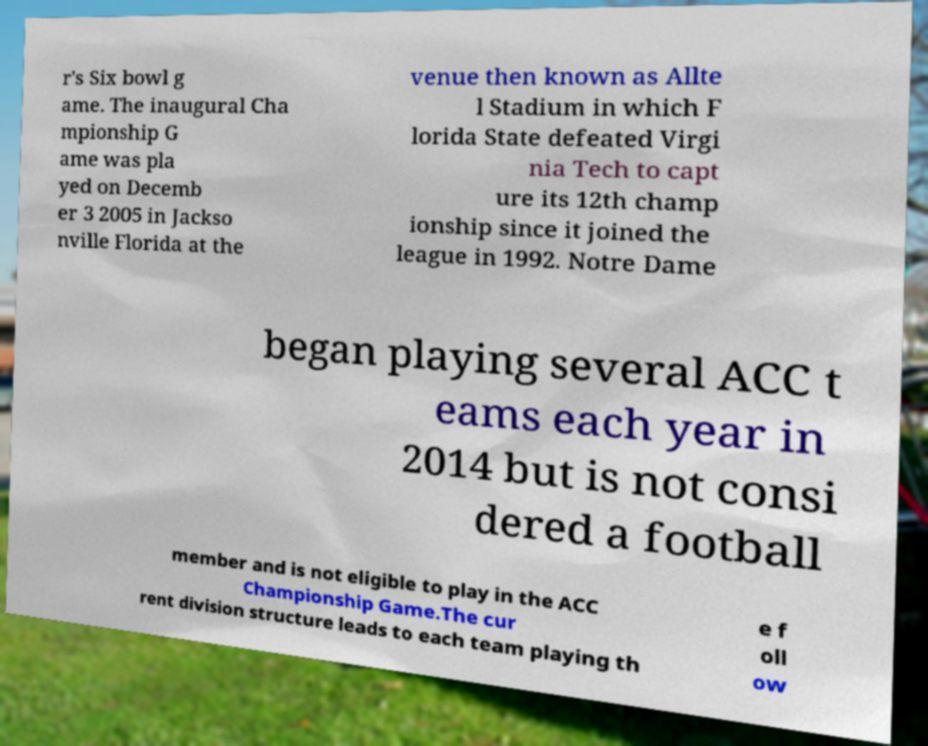Please identify and transcribe the text found in this image. r's Six bowl g ame. The inaugural Cha mpionship G ame was pla yed on Decemb er 3 2005 in Jackso nville Florida at the venue then known as Allte l Stadium in which F lorida State defeated Virgi nia Tech to capt ure its 12th champ ionship since it joined the league in 1992. Notre Dame began playing several ACC t eams each year in 2014 but is not consi dered a football member and is not eligible to play in the ACC Championship Game.The cur rent division structure leads to each team playing th e f oll ow 